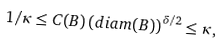<formula> <loc_0><loc_0><loc_500><loc_500>1 / \kappa \leq C ( B ) \left ( d i a m ( B ) \right ) ^ { \delta / 2 } \leq \kappa ,</formula> 